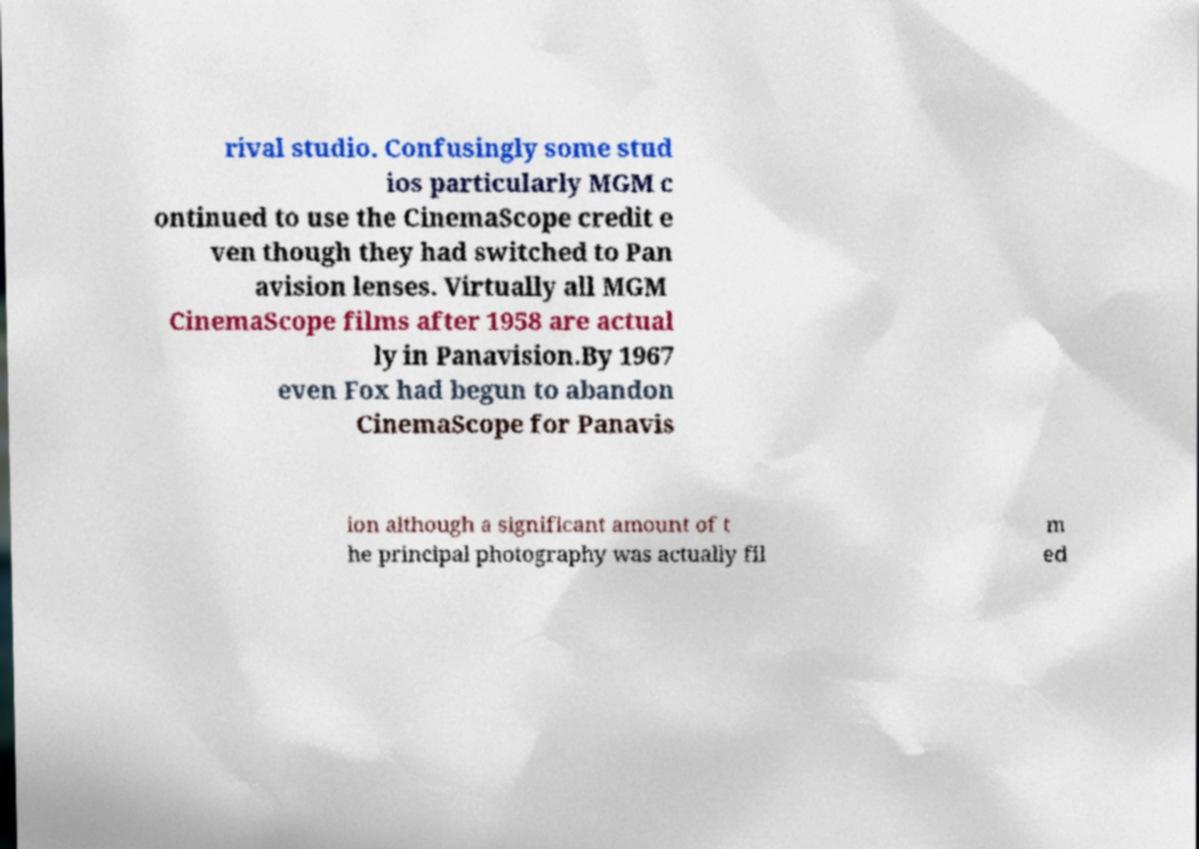For documentation purposes, I need the text within this image transcribed. Could you provide that? rival studio. Confusingly some stud ios particularly MGM c ontinued to use the CinemaScope credit e ven though they had switched to Pan avision lenses. Virtually all MGM CinemaScope films after 1958 are actual ly in Panavision.By 1967 even Fox had begun to abandon CinemaScope for Panavis ion although a significant amount of t he principal photography was actually fil m ed 